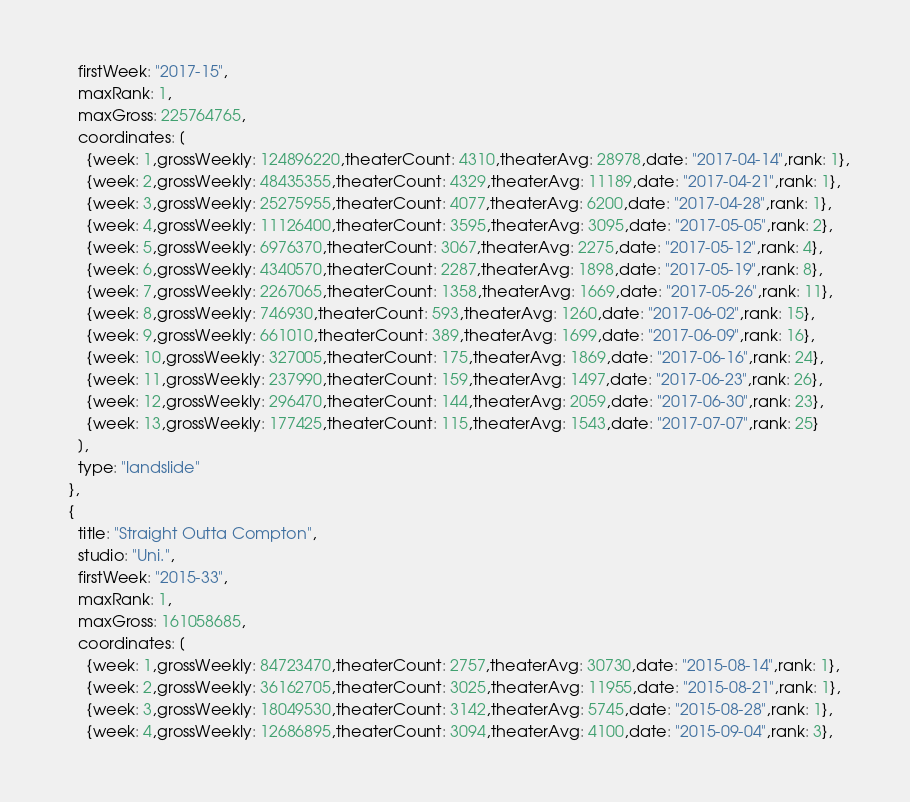Convert code to text. <code><loc_0><loc_0><loc_500><loc_500><_JavaScript_>    firstWeek: "2017-15",
    maxRank: 1,
    maxGross: 225764765,
    coordinates: [
      {week: 1,grossWeekly: 124896220,theaterCount: 4310,theaterAvg: 28978,date: "2017-04-14",rank: 1},
      {week: 2,grossWeekly: 48435355,theaterCount: 4329,theaterAvg: 11189,date: "2017-04-21",rank: 1},
      {week: 3,grossWeekly: 25275955,theaterCount: 4077,theaterAvg: 6200,date: "2017-04-28",rank: 1},
      {week: 4,grossWeekly: 11126400,theaterCount: 3595,theaterAvg: 3095,date: "2017-05-05",rank: 2},
      {week: 5,grossWeekly: 6976370,theaterCount: 3067,theaterAvg: 2275,date: "2017-05-12",rank: 4},
      {week: 6,grossWeekly: 4340570,theaterCount: 2287,theaterAvg: 1898,date: "2017-05-19",rank: 8},
      {week: 7,grossWeekly: 2267065,theaterCount: 1358,theaterAvg: 1669,date: "2017-05-26",rank: 11},
      {week: 8,grossWeekly: 746930,theaterCount: 593,theaterAvg: 1260,date: "2017-06-02",rank: 15},
      {week: 9,grossWeekly: 661010,theaterCount: 389,theaterAvg: 1699,date: "2017-06-09",rank: 16},
      {week: 10,grossWeekly: 327005,theaterCount: 175,theaterAvg: 1869,date: "2017-06-16",rank: 24},
      {week: 11,grossWeekly: 237990,theaterCount: 159,theaterAvg: 1497,date: "2017-06-23",rank: 26},
      {week: 12,grossWeekly: 296470,theaterCount: 144,theaterAvg: 2059,date: "2017-06-30",rank: 23},
      {week: 13,grossWeekly: 177425,theaterCount: 115,theaterAvg: 1543,date: "2017-07-07",rank: 25}
    ],
    type: "landslide"
  },
  {
    title: "Straight Outta Compton",
    studio: "Uni.",
    firstWeek: "2015-33",
    maxRank: 1,
    maxGross: 161058685,
    coordinates: [
      {week: 1,grossWeekly: 84723470,theaterCount: 2757,theaterAvg: 30730,date: "2015-08-14",rank: 1},
      {week: 2,grossWeekly: 36162705,theaterCount: 3025,theaterAvg: 11955,date: "2015-08-21",rank: 1},
      {week: 3,grossWeekly: 18049530,theaterCount: 3142,theaterAvg: 5745,date: "2015-08-28",rank: 1},
      {week: 4,grossWeekly: 12686895,theaterCount: 3094,theaterAvg: 4100,date: "2015-09-04",rank: 3},</code> 